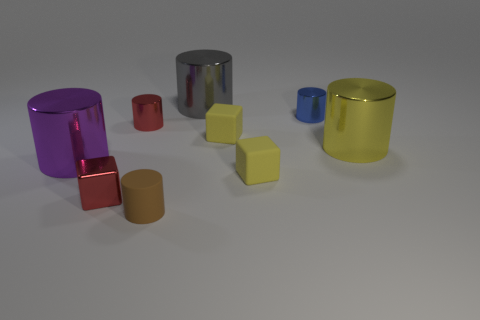Subtract all large gray cylinders. How many cylinders are left? 5 Subtract all yellow blocks. How many blocks are left? 1 Subtract 2 cubes. How many cubes are left? 1 Subtract all yellow cylinders. Subtract all small red metal cubes. How many objects are left? 7 Add 6 tiny red things. How many tiny red things are left? 8 Add 1 tiny blue shiny things. How many tiny blue shiny things exist? 2 Subtract 1 yellow blocks. How many objects are left? 8 Subtract all blocks. How many objects are left? 6 Subtract all gray cylinders. Subtract all brown blocks. How many cylinders are left? 5 Subtract all yellow blocks. How many yellow cylinders are left? 1 